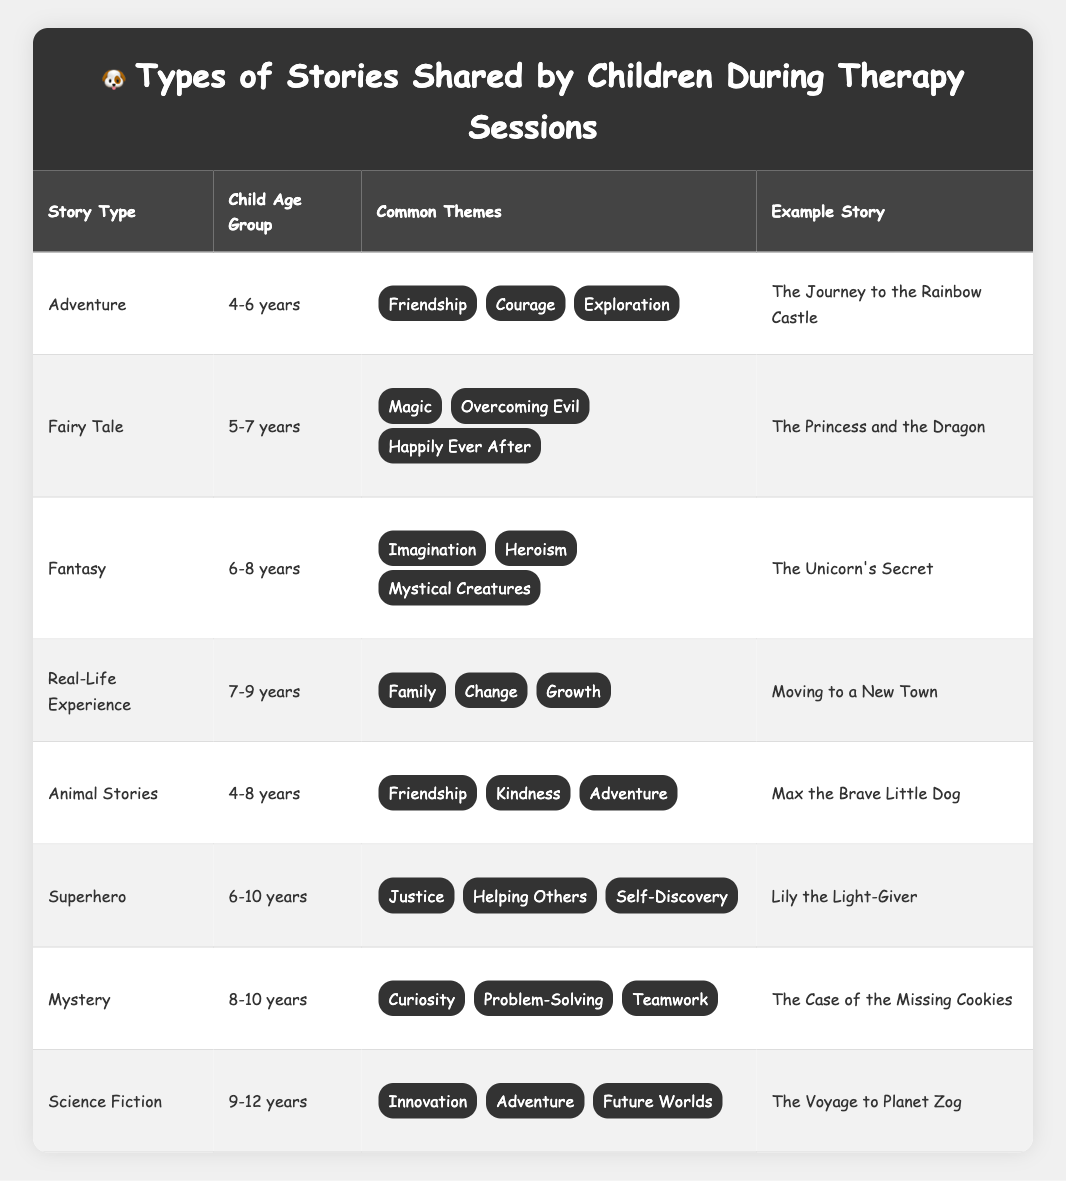What is the story type most commonly associated with the age group 4-6 years? In the table, the story type listed for the age group 4-6 years is "Adventure" and "Animal Stories." However, "Adventure" is listed first, so it can be considered the most common.
Answer: Adventure Which story involves themes of "Justice" and "Helping Others"? Looking through the table, the "Superhero" story type contains both themes of "Justice" and "Helping Others," with the example story being "Lily the Light-Giver."
Answer: Lily the Light-Giver How many different story types are shared by children aged 6-10 years? The age group 6-10 years has two story types associated with it, which are "Fantasy" and "Superhero."
Answer: 2 Is there a story type that includes themes of both "Friendship" and "Adventure"? The "Animal Stories" story type includes both themes, as listed in the table. Therefore, the statement is true.
Answer: Yes What is the average child age group for the stories in the table? Calculating the age groups: 4-6, 5-7, 6-8, 7-9, 4-8, 6-10, 8-10, and 9-12, we can deduce the age range is from 4 to 12 with most types skewing towards younger ages. The average can be complex due to varying ranges but is generally between 6-10 years.
Answer: 6-10 years (approx.) How many stories are categorized under the age group 8-10 years? The only story type listed for the 8-10 years age group is "Mystery," which has one example story, "The Case of the Missing Cookies."
Answer: 1 Which story type has the most common themes involved? Comparing the common themes across the table, "Adventure" and "Animal Stories" both share three themes each: "Friendship," "Courage," and "Exploration" for Adventure, and "Friendship," "Kindness," and "Adventure" for Animal Stories.
Answer: 3 themes (tie) What theme appears in both "Real-Life Experience" and "Animal Stories" story types? Upon checking the themes listed for "Real-Life Experience," which includes "Family," "Change," and "Growth," and for "Animal Stories," which includes "Friendship," "Kindness," and "Adventure," there are no common themes between them. Hence, no themes appear in both.
Answer: No common theme Which story has the theme "Curiosity"? Looking under the "Mystery" story type in the table, the theme "Curiosity" is listed along with the example story "The Case of the Missing Cookies."
Answer: The Case of the Missing Cookies What would be a suitable story type for a 10-year-old child based on the table? The table lists "Superhero" for ages 6-10 years and "Mystery" for ages 8-10 years. Both would be suitable story types for a 10-year-old child.
Answer: Superhero or Mystery 